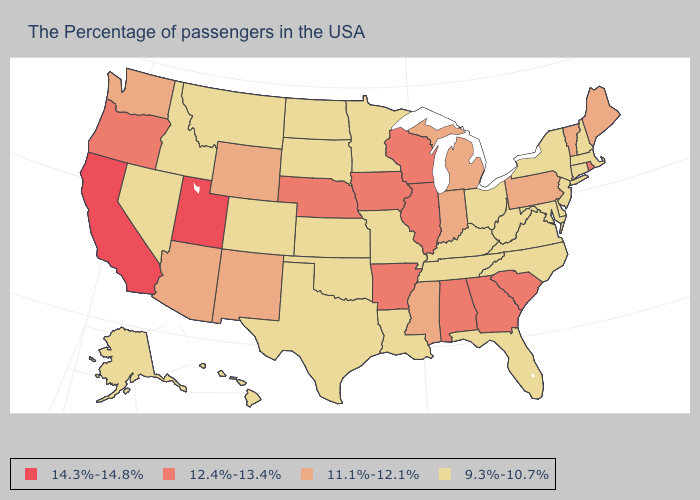Does California have the highest value in the USA?
Answer briefly. Yes. Is the legend a continuous bar?
Concise answer only. No. Name the states that have a value in the range 11.1%-12.1%?
Concise answer only. Maine, Vermont, Pennsylvania, Michigan, Indiana, Mississippi, Wyoming, New Mexico, Arizona, Washington. Name the states that have a value in the range 12.4%-13.4%?
Give a very brief answer. Rhode Island, South Carolina, Georgia, Alabama, Wisconsin, Illinois, Arkansas, Iowa, Nebraska, Oregon. What is the lowest value in the USA?
Quick response, please. 9.3%-10.7%. What is the highest value in states that border Michigan?
Give a very brief answer. 12.4%-13.4%. Name the states that have a value in the range 12.4%-13.4%?
Answer briefly. Rhode Island, South Carolina, Georgia, Alabama, Wisconsin, Illinois, Arkansas, Iowa, Nebraska, Oregon. Does Rhode Island have the highest value in the Northeast?
Give a very brief answer. Yes. Is the legend a continuous bar?
Write a very short answer. No. What is the highest value in the USA?
Write a very short answer. 14.3%-14.8%. What is the value of Rhode Island?
Concise answer only. 12.4%-13.4%. Is the legend a continuous bar?
Answer briefly. No. Which states have the lowest value in the USA?
Short answer required. Massachusetts, New Hampshire, Connecticut, New York, New Jersey, Delaware, Maryland, Virginia, North Carolina, West Virginia, Ohio, Florida, Kentucky, Tennessee, Louisiana, Missouri, Minnesota, Kansas, Oklahoma, Texas, South Dakota, North Dakota, Colorado, Montana, Idaho, Nevada, Alaska, Hawaii. Name the states that have a value in the range 9.3%-10.7%?
Write a very short answer. Massachusetts, New Hampshire, Connecticut, New York, New Jersey, Delaware, Maryland, Virginia, North Carolina, West Virginia, Ohio, Florida, Kentucky, Tennessee, Louisiana, Missouri, Minnesota, Kansas, Oklahoma, Texas, South Dakota, North Dakota, Colorado, Montana, Idaho, Nevada, Alaska, Hawaii. What is the value of Texas?
Quick response, please. 9.3%-10.7%. 